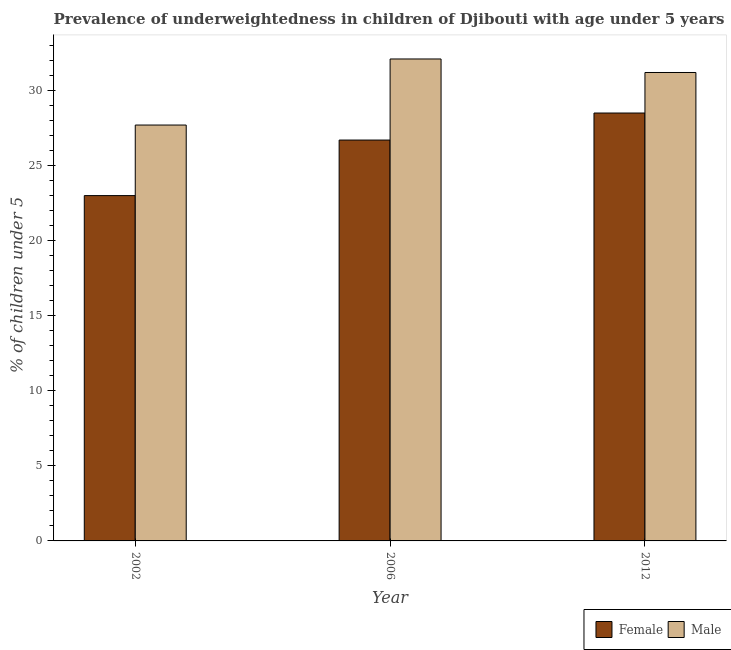How many different coloured bars are there?
Give a very brief answer. 2. Are the number of bars per tick equal to the number of legend labels?
Provide a short and direct response. Yes. Are the number of bars on each tick of the X-axis equal?
Give a very brief answer. Yes. Across all years, what is the minimum percentage of underweighted male children?
Offer a very short reply. 27.7. In which year was the percentage of underweighted male children maximum?
Your answer should be very brief. 2006. In which year was the percentage of underweighted male children minimum?
Give a very brief answer. 2002. What is the total percentage of underweighted male children in the graph?
Your answer should be very brief. 91. What is the average percentage of underweighted male children per year?
Offer a very short reply. 30.33. In the year 2002, what is the difference between the percentage of underweighted female children and percentage of underweighted male children?
Make the answer very short. 0. What is the ratio of the percentage of underweighted male children in 2006 to that in 2012?
Your response must be concise. 1.03. Is the percentage of underweighted male children in 2006 less than that in 2012?
Offer a very short reply. No. Is the difference between the percentage of underweighted female children in 2002 and 2012 greater than the difference between the percentage of underweighted male children in 2002 and 2012?
Ensure brevity in your answer.  No. What is the difference between the highest and the second highest percentage of underweighted female children?
Make the answer very short. 1.8. What is the difference between the highest and the lowest percentage of underweighted male children?
Offer a terse response. 4.4. In how many years, is the percentage of underweighted female children greater than the average percentage of underweighted female children taken over all years?
Keep it short and to the point. 2. Is the sum of the percentage of underweighted male children in 2006 and 2012 greater than the maximum percentage of underweighted female children across all years?
Provide a succinct answer. Yes. Are all the bars in the graph horizontal?
Give a very brief answer. No. What is the difference between two consecutive major ticks on the Y-axis?
Your answer should be very brief. 5. Are the values on the major ticks of Y-axis written in scientific E-notation?
Your answer should be compact. No. Does the graph contain any zero values?
Provide a succinct answer. No. How many legend labels are there?
Keep it short and to the point. 2. How are the legend labels stacked?
Provide a succinct answer. Horizontal. What is the title of the graph?
Give a very brief answer. Prevalence of underweightedness in children of Djibouti with age under 5 years. What is the label or title of the Y-axis?
Offer a terse response.  % of children under 5. What is the  % of children under 5 of Male in 2002?
Your answer should be very brief. 27.7. What is the  % of children under 5 of Female in 2006?
Offer a terse response. 26.7. What is the  % of children under 5 of Male in 2006?
Give a very brief answer. 32.1. What is the  % of children under 5 in Female in 2012?
Offer a terse response. 28.5. What is the  % of children under 5 of Male in 2012?
Keep it short and to the point. 31.2. Across all years, what is the maximum  % of children under 5 of Female?
Your answer should be very brief. 28.5. Across all years, what is the maximum  % of children under 5 of Male?
Your response must be concise. 32.1. Across all years, what is the minimum  % of children under 5 in Male?
Provide a succinct answer. 27.7. What is the total  % of children under 5 of Female in the graph?
Provide a succinct answer. 78.2. What is the total  % of children under 5 of Male in the graph?
Offer a very short reply. 91. What is the difference between the  % of children under 5 of Female in 2002 and that in 2006?
Your response must be concise. -3.7. What is the difference between the  % of children under 5 of Male in 2002 and that in 2006?
Offer a terse response. -4.4. What is the difference between the  % of children under 5 in Female in 2002 and that in 2012?
Offer a very short reply. -5.5. What is the difference between the  % of children under 5 in Male in 2006 and that in 2012?
Your answer should be very brief. 0.9. What is the difference between the  % of children under 5 of Female in 2002 and the  % of children under 5 of Male in 2012?
Ensure brevity in your answer.  -8.2. What is the average  % of children under 5 in Female per year?
Provide a succinct answer. 26.07. What is the average  % of children under 5 in Male per year?
Your answer should be very brief. 30.33. In the year 2006, what is the difference between the  % of children under 5 of Female and  % of children under 5 of Male?
Your response must be concise. -5.4. What is the ratio of the  % of children under 5 in Female in 2002 to that in 2006?
Your response must be concise. 0.86. What is the ratio of the  % of children under 5 of Male in 2002 to that in 2006?
Provide a short and direct response. 0.86. What is the ratio of the  % of children under 5 of Female in 2002 to that in 2012?
Offer a very short reply. 0.81. What is the ratio of the  % of children under 5 of Male in 2002 to that in 2012?
Make the answer very short. 0.89. What is the ratio of the  % of children under 5 of Female in 2006 to that in 2012?
Keep it short and to the point. 0.94. What is the ratio of the  % of children under 5 of Male in 2006 to that in 2012?
Your answer should be compact. 1.03. What is the difference between the highest and the second highest  % of children under 5 in Male?
Make the answer very short. 0.9. 